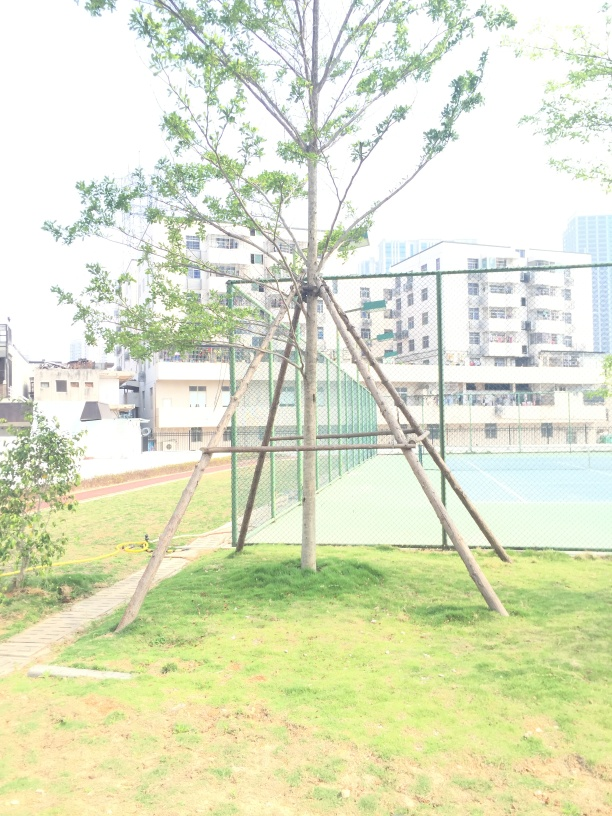What time of day does it seem to be in this image? Considering the bright lighting and the shadows under the tree, it suggests midday when the sun is at its highest, leading to the overexposed areas of the image. 